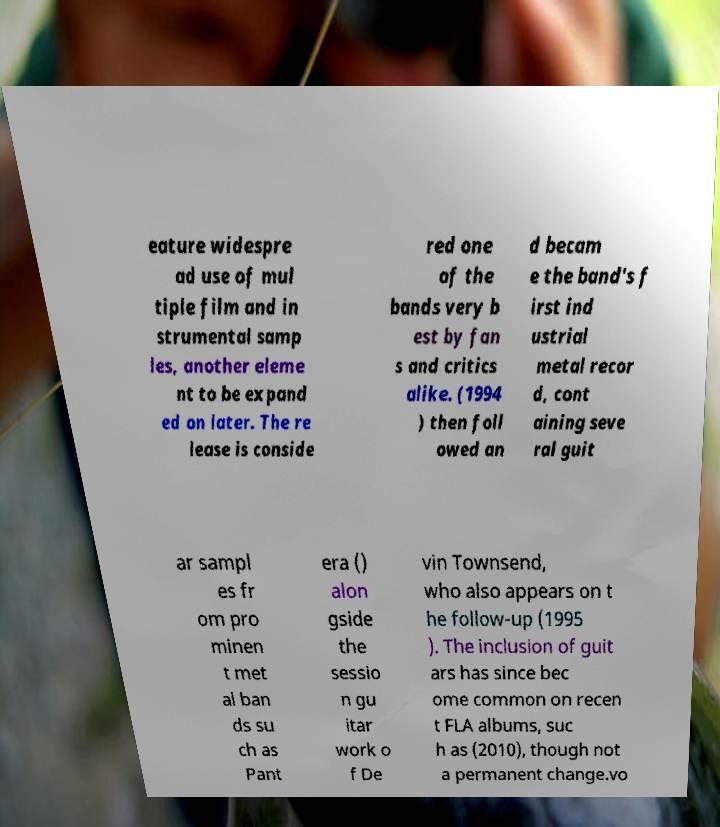Can you read and provide the text displayed in the image?This photo seems to have some interesting text. Can you extract and type it out for me? eature widespre ad use of mul tiple film and in strumental samp les, another eleme nt to be expand ed on later. The re lease is conside red one of the bands very b est by fan s and critics alike. (1994 ) then foll owed an d becam e the band's f irst ind ustrial metal recor d, cont aining seve ral guit ar sampl es fr om pro minen t met al ban ds su ch as Pant era () alon gside the sessio n gu itar work o f De vin Townsend, who also appears on t he follow-up (1995 ). The inclusion of guit ars has since bec ome common on recen t FLA albums, suc h as (2010), though not a permanent change.vo 